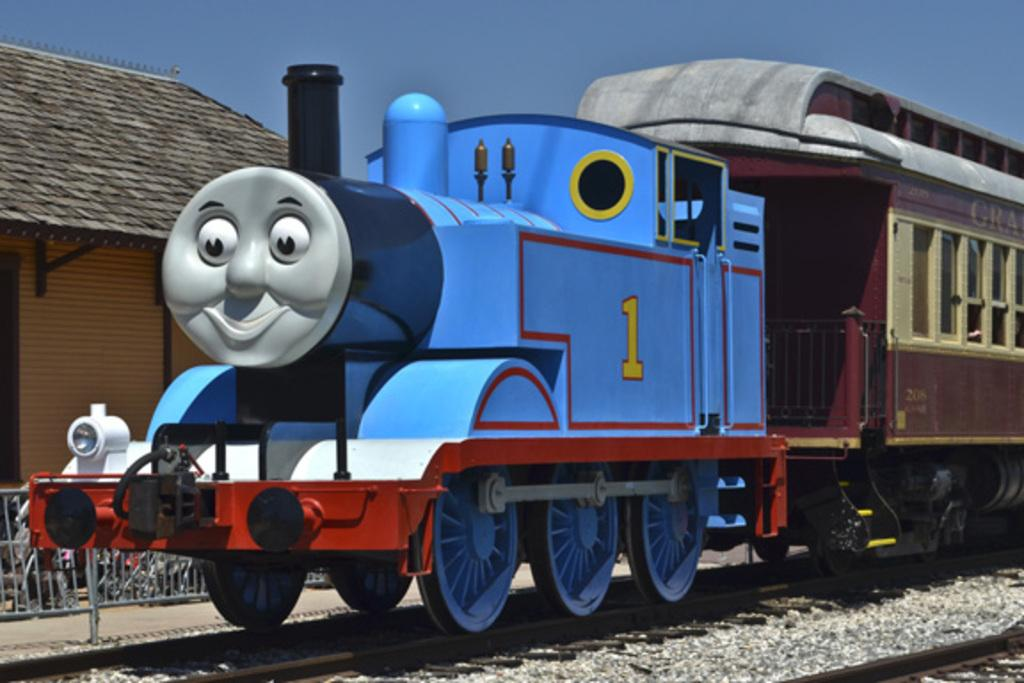<image>
Create a compact narrative representing the image presented. a large as life kiddie style train with a cartoon face and #1 on the side. 